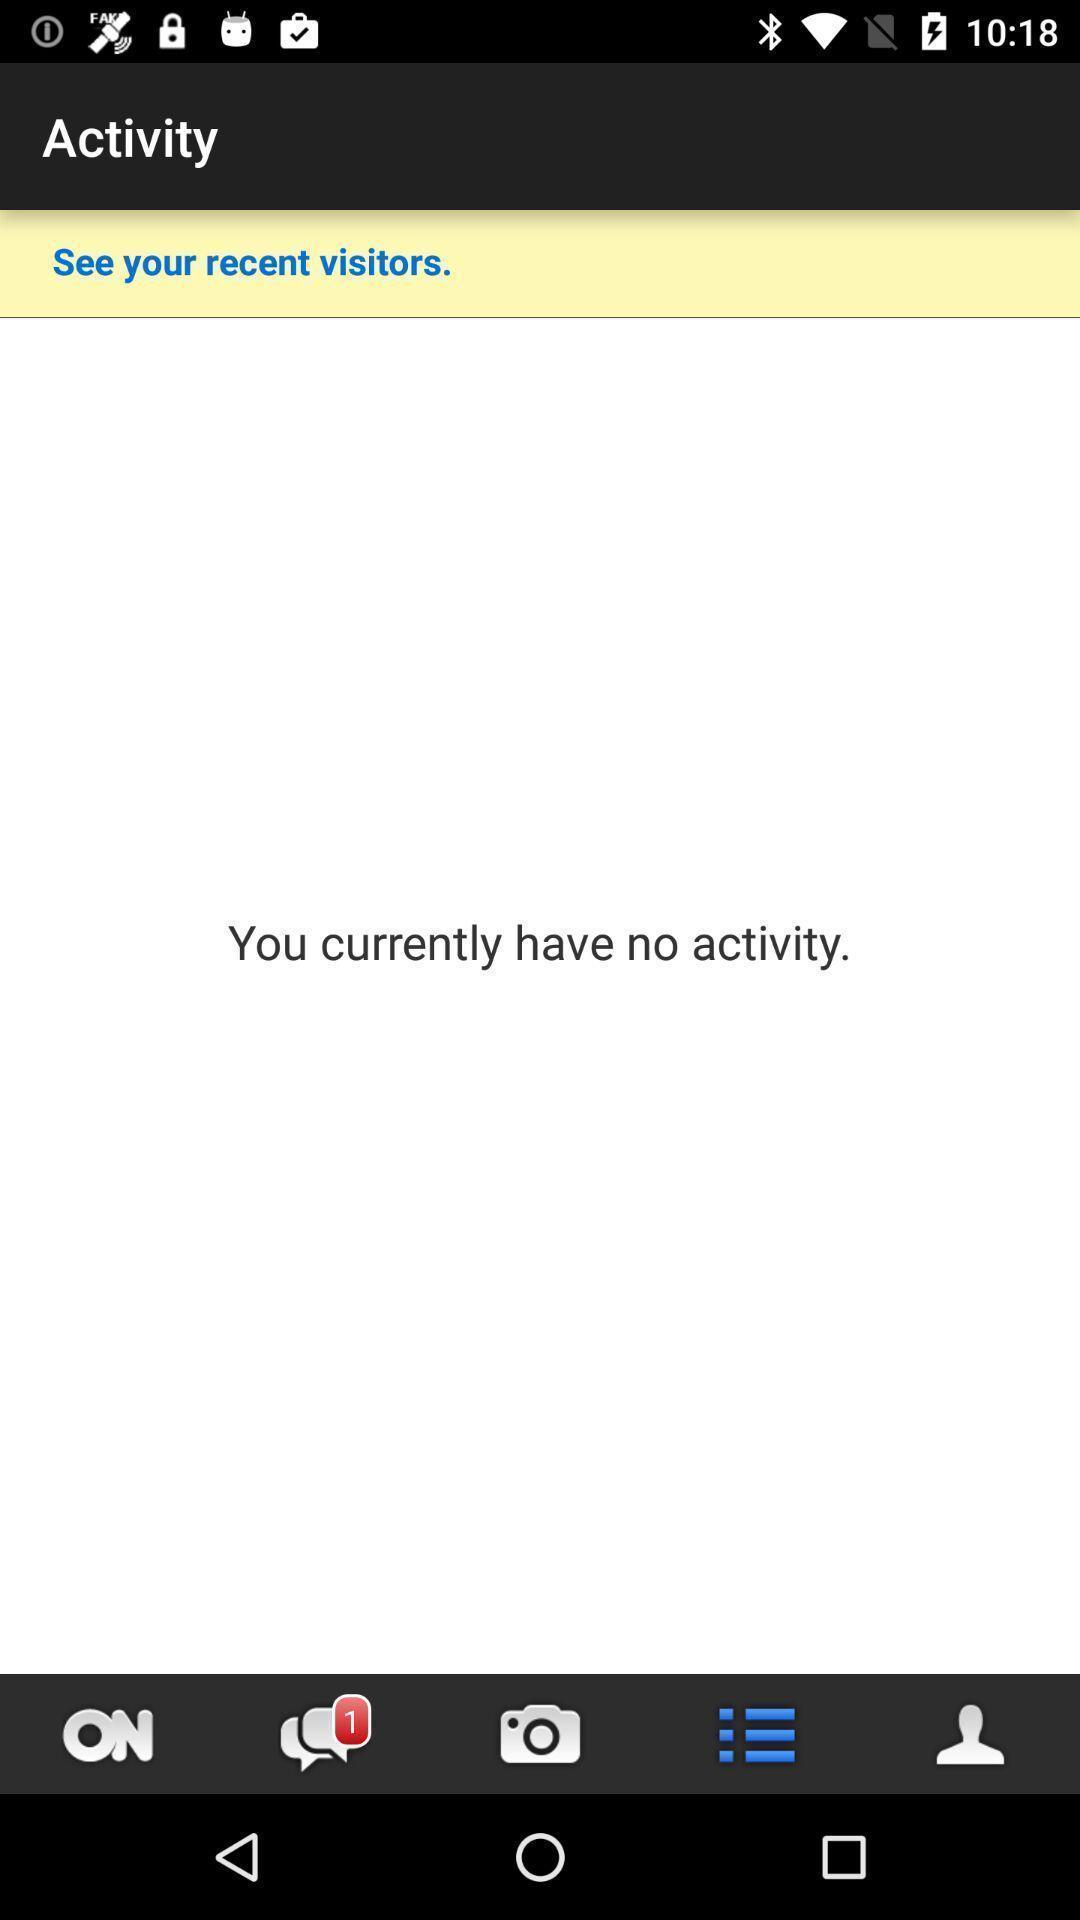Give me a summary of this screen capture. Page displaying no current activity. 